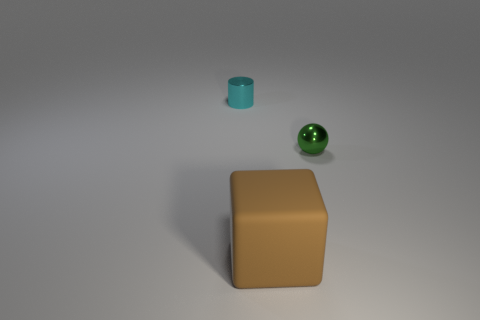What number of other things are the same size as the green thing?
Your answer should be very brief. 1. What size is the object that is behind the large matte cube and in front of the cyan shiny cylinder?
Offer a terse response. Small. There is a small shiny cylinder; is it the same color as the shiny thing on the right side of the big rubber block?
Provide a succinct answer. No. Are there any other small cyan metallic objects that have the same shape as the cyan metallic object?
Ensure brevity in your answer.  No. How many objects are either tiny green metal objects or objects left of the brown rubber cube?
Ensure brevity in your answer.  2. How many other objects are the same material as the cylinder?
Provide a succinct answer. 1. What number of objects are tiny blue metallic cylinders or big brown blocks?
Offer a very short reply. 1. Is the number of small objects that are to the right of the cyan thing greater than the number of tiny cyan shiny cylinders that are in front of the small green metal ball?
Your answer should be very brief. Yes. Does the small metal object behind the green ball have the same color as the object that is in front of the green sphere?
Ensure brevity in your answer.  No. There is a object that is behind the metallic object that is to the right of the small object on the left side of the tiny green metal ball; what size is it?
Your answer should be compact. Small. 